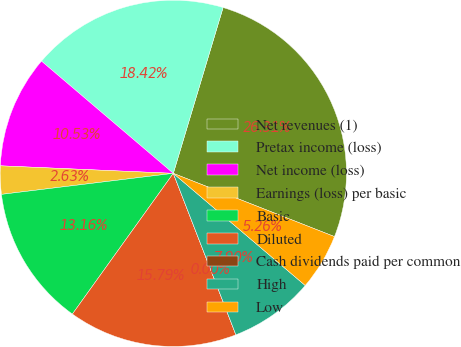Convert chart to OTSL. <chart><loc_0><loc_0><loc_500><loc_500><pie_chart><fcel>Net revenues (1)<fcel>Pretax income (loss)<fcel>Net income (loss)<fcel>Earnings (loss) per basic<fcel>Basic<fcel>Diluted<fcel>Cash dividends paid per common<fcel>High<fcel>Low<nl><fcel>26.31%<fcel>18.42%<fcel>10.53%<fcel>2.63%<fcel>13.16%<fcel>15.79%<fcel>0.0%<fcel>7.9%<fcel>5.26%<nl></chart> 